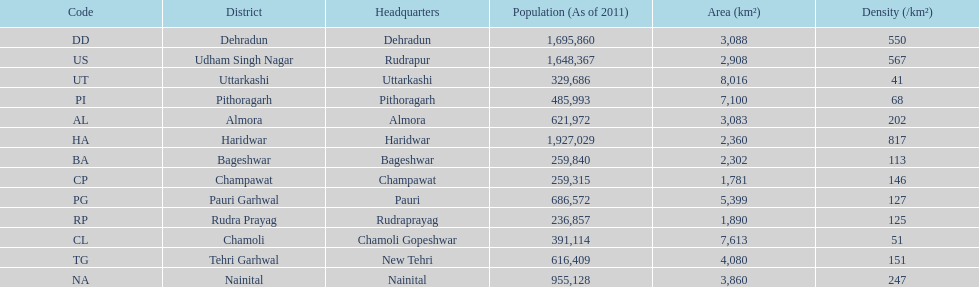Which has a larger population, dehradun or nainital? Dehradun. 